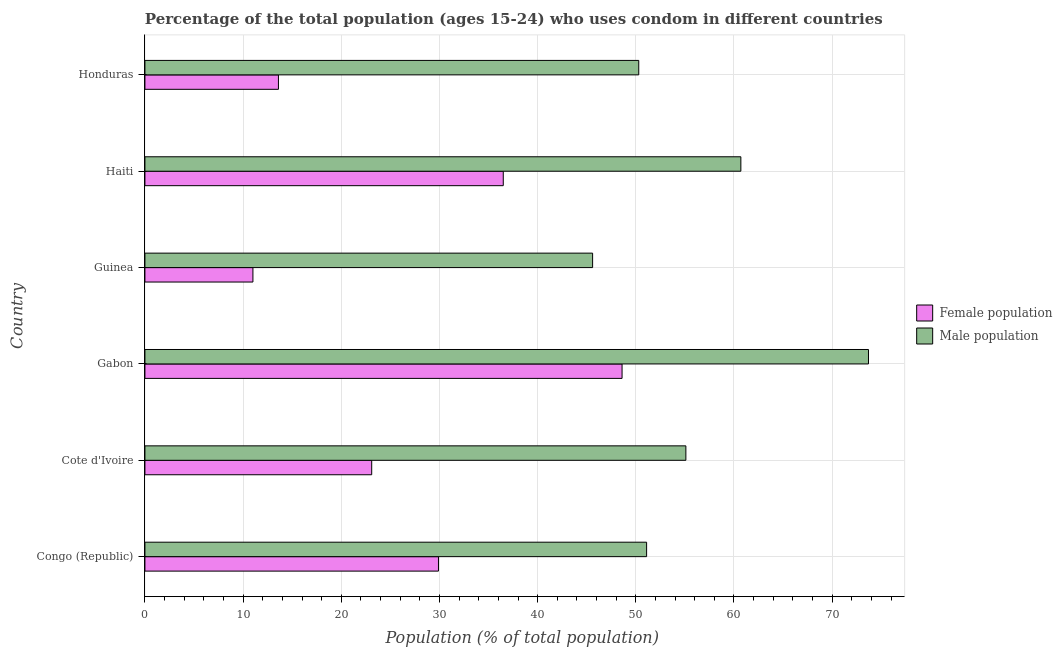Are the number of bars on each tick of the Y-axis equal?
Your answer should be very brief. Yes. How many bars are there on the 4th tick from the bottom?
Make the answer very short. 2. What is the label of the 6th group of bars from the top?
Give a very brief answer. Congo (Republic). What is the female population in Haiti?
Your response must be concise. 36.5. Across all countries, what is the maximum male population?
Give a very brief answer. 73.7. Across all countries, what is the minimum female population?
Give a very brief answer. 11. In which country was the female population maximum?
Your answer should be very brief. Gabon. In which country was the female population minimum?
Give a very brief answer. Guinea. What is the total female population in the graph?
Your answer should be compact. 162.7. What is the difference between the male population in Honduras and the female population in Haiti?
Give a very brief answer. 13.8. What is the average female population per country?
Your answer should be very brief. 27.12. What is the difference between the female population and male population in Guinea?
Offer a terse response. -34.6. In how many countries, is the male population greater than 28 %?
Offer a terse response. 6. What is the ratio of the female population in Congo (Republic) to that in Honduras?
Provide a succinct answer. 2.2. Is the female population in Congo (Republic) less than that in Haiti?
Your answer should be very brief. Yes. What is the difference between the highest and the lowest male population?
Provide a succinct answer. 28.1. In how many countries, is the female population greater than the average female population taken over all countries?
Make the answer very short. 3. What does the 2nd bar from the top in Congo (Republic) represents?
Provide a succinct answer. Female population. What does the 2nd bar from the bottom in Congo (Republic) represents?
Your answer should be compact. Male population. How many bars are there?
Make the answer very short. 12. Are all the bars in the graph horizontal?
Offer a terse response. Yes. How many countries are there in the graph?
Give a very brief answer. 6. What is the difference between two consecutive major ticks on the X-axis?
Offer a very short reply. 10. How are the legend labels stacked?
Keep it short and to the point. Vertical. What is the title of the graph?
Provide a short and direct response. Percentage of the total population (ages 15-24) who uses condom in different countries. What is the label or title of the X-axis?
Your answer should be very brief. Population (% of total population) . What is the Population (% of total population)  of Female population in Congo (Republic)?
Give a very brief answer. 29.9. What is the Population (% of total population)  in Male population in Congo (Republic)?
Offer a terse response. 51.1. What is the Population (% of total population)  of Female population in Cote d'Ivoire?
Ensure brevity in your answer.  23.1. What is the Population (% of total population)  in Male population in Cote d'Ivoire?
Provide a succinct answer. 55.1. What is the Population (% of total population)  in Female population in Gabon?
Your response must be concise. 48.6. What is the Population (% of total population)  in Male population in Gabon?
Your answer should be compact. 73.7. What is the Population (% of total population)  of Female population in Guinea?
Your response must be concise. 11. What is the Population (% of total population)  of Male population in Guinea?
Ensure brevity in your answer.  45.6. What is the Population (% of total population)  of Female population in Haiti?
Keep it short and to the point. 36.5. What is the Population (% of total population)  in Male population in Haiti?
Ensure brevity in your answer.  60.7. What is the Population (% of total population)  in Male population in Honduras?
Your response must be concise. 50.3. Across all countries, what is the maximum Population (% of total population)  of Female population?
Ensure brevity in your answer.  48.6. Across all countries, what is the maximum Population (% of total population)  in Male population?
Offer a terse response. 73.7. Across all countries, what is the minimum Population (% of total population)  of Female population?
Your answer should be very brief. 11. Across all countries, what is the minimum Population (% of total population)  in Male population?
Your answer should be compact. 45.6. What is the total Population (% of total population)  of Female population in the graph?
Keep it short and to the point. 162.7. What is the total Population (% of total population)  of Male population in the graph?
Provide a short and direct response. 336.5. What is the difference between the Population (% of total population)  of Male population in Congo (Republic) and that in Cote d'Ivoire?
Make the answer very short. -4. What is the difference between the Population (% of total population)  in Female population in Congo (Republic) and that in Gabon?
Your answer should be very brief. -18.7. What is the difference between the Population (% of total population)  in Male population in Congo (Republic) and that in Gabon?
Give a very brief answer. -22.6. What is the difference between the Population (% of total population)  in Male population in Congo (Republic) and that in Guinea?
Give a very brief answer. 5.5. What is the difference between the Population (% of total population)  in Female population in Congo (Republic) and that in Haiti?
Your response must be concise. -6.6. What is the difference between the Population (% of total population)  in Female population in Congo (Republic) and that in Honduras?
Provide a succinct answer. 16.3. What is the difference between the Population (% of total population)  in Male population in Congo (Republic) and that in Honduras?
Your answer should be very brief. 0.8. What is the difference between the Population (% of total population)  in Female population in Cote d'Ivoire and that in Gabon?
Offer a terse response. -25.5. What is the difference between the Population (% of total population)  of Male population in Cote d'Ivoire and that in Gabon?
Give a very brief answer. -18.6. What is the difference between the Population (% of total population)  of Female population in Cote d'Ivoire and that in Guinea?
Offer a very short reply. 12.1. What is the difference between the Population (% of total population)  of Male population in Cote d'Ivoire and that in Guinea?
Your answer should be very brief. 9.5. What is the difference between the Population (% of total population)  in Male population in Cote d'Ivoire and that in Haiti?
Offer a very short reply. -5.6. What is the difference between the Population (% of total population)  of Female population in Cote d'Ivoire and that in Honduras?
Ensure brevity in your answer.  9.5. What is the difference between the Population (% of total population)  of Female population in Gabon and that in Guinea?
Your answer should be very brief. 37.6. What is the difference between the Population (% of total population)  in Male population in Gabon and that in Guinea?
Offer a terse response. 28.1. What is the difference between the Population (% of total population)  in Female population in Gabon and that in Haiti?
Keep it short and to the point. 12.1. What is the difference between the Population (% of total population)  of Male population in Gabon and that in Haiti?
Provide a succinct answer. 13. What is the difference between the Population (% of total population)  in Male population in Gabon and that in Honduras?
Your answer should be very brief. 23.4. What is the difference between the Population (% of total population)  in Female population in Guinea and that in Haiti?
Offer a terse response. -25.5. What is the difference between the Population (% of total population)  in Male population in Guinea and that in Haiti?
Give a very brief answer. -15.1. What is the difference between the Population (% of total population)  in Female population in Haiti and that in Honduras?
Give a very brief answer. 22.9. What is the difference between the Population (% of total population)  of Male population in Haiti and that in Honduras?
Provide a short and direct response. 10.4. What is the difference between the Population (% of total population)  of Female population in Congo (Republic) and the Population (% of total population)  of Male population in Cote d'Ivoire?
Your answer should be compact. -25.2. What is the difference between the Population (% of total population)  in Female population in Congo (Republic) and the Population (% of total population)  in Male population in Gabon?
Make the answer very short. -43.8. What is the difference between the Population (% of total population)  in Female population in Congo (Republic) and the Population (% of total population)  in Male population in Guinea?
Make the answer very short. -15.7. What is the difference between the Population (% of total population)  in Female population in Congo (Republic) and the Population (% of total population)  in Male population in Haiti?
Provide a short and direct response. -30.8. What is the difference between the Population (% of total population)  in Female population in Congo (Republic) and the Population (% of total population)  in Male population in Honduras?
Offer a terse response. -20.4. What is the difference between the Population (% of total population)  in Female population in Cote d'Ivoire and the Population (% of total population)  in Male population in Gabon?
Offer a very short reply. -50.6. What is the difference between the Population (% of total population)  of Female population in Cote d'Ivoire and the Population (% of total population)  of Male population in Guinea?
Provide a succinct answer. -22.5. What is the difference between the Population (% of total population)  in Female population in Cote d'Ivoire and the Population (% of total population)  in Male population in Haiti?
Offer a terse response. -37.6. What is the difference between the Population (% of total population)  of Female population in Cote d'Ivoire and the Population (% of total population)  of Male population in Honduras?
Provide a short and direct response. -27.2. What is the difference between the Population (% of total population)  of Female population in Guinea and the Population (% of total population)  of Male population in Haiti?
Provide a short and direct response. -49.7. What is the difference between the Population (% of total population)  in Female population in Guinea and the Population (% of total population)  in Male population in Honduras?
Your answer should be compact. -39.3. What is the difference between the Population (% of total population)  in Female population in Haiti and the Population (% of total population)  in Male population in Honduras?
Your answer should be compact. -13.8. What is the average Population (% of total population)  of Female population per country?
Provide a succinct answer. 27.12. What is the average Population (% of total population)  of Male population per country?
Your answer should be compact. 56.08. What is the difference between the Population (% of total population)  of Female population and Population (% of total population)  of Male population in Congo (Republic)?
Keep it short and to the point. -21.2. What is the difference between the Population (% of total population)  of Female population and Population (% of total population)  of Male population in Cote d'Ivoire?
Offer a terse response. -32. What is the difference between the Population (% of total population)  of Female population and Population (% of total population)  of Male population in Gabon?
Make the answer very short. -25.1. What is the difference between the Population (% of total population)  in Female population and Population (% of total population)  in Male population in Guinea?
Offer a terse response. -34.6. What is the difference between the Population (% of total population)  in Female population and Population (% of total population)  in Male population in Haiti?
Ensure brevity in your answer.  -24.2. What is the difference between the Population (% of total population)  of Female population and Population (% of total population)  of Male population in Honduras?
Make the answer very short. -36.7. What is the ratio of the Population (% of total population)  in Female population in Congo (Republic) to that in Cote d'Ivoire?
Provide a short and direct response. 1.29. What is the ratio of the Population (% of total population)  of Male population in Congo (Republic) to that in Cote d'Ivoire?
Give a very brief answer. 0.93. What is the ratio of the Population (% of total population)  of Female population in Congo (Republic) to that in Gabon?
Your answer should be compact. 0.62. What is the ratio of the Population (% of total population)  of Male population in Congo (Republic) to that in Gabon?
Keep it short and to the point. 0.69. What is the ratio of the Population (% of total population)  of Female population in Congo (Republic) to that in Guinea?
Your answer should be very brief. 2.72. What is the ratio of the Population (% of total population)  in Male population in Congo (Republic) to that in Guinea?
Provide a succinct answer. 1.12. What is the ratio of the Population (% of total population)  in Female population in Congo (Republic) to that in Haiti?
Offer a very short reply. 0.82. What is the ratio of the Population (% of total population)  of Male population in Congo (Republic) to that in Haiti?
Keep it short and to the point. 0.84. What is the ratio of the Population (% of total population)  of Female population in Congo (Republic) to that in Honduras?
Your response must be concise. 2.2. What is the ratio of the Population (% of total population)  of Male population in Congo (Republic) to that in Honduras?
Provide a short and direct response. 1.02. What is the ratio of the Population (% of total population)  of Female population in Cote d'Ivoire to that in Gabon?
Keep it short and to the point. 0.48. What is the ratio of the Population (% of total population)  of Male population in Cote d'Ivoire to that in Gabon?
Make the answer very short. 0.75. What is the ratio of the Population (% of total population)  in Female population in Cote d'Ivoire to that in Guinea?
Offer a terse response. 2.1. What is the ratio of the Population (% of total population)  of Male population in Cote d'Ivoire to that in Guinea?
Keep it short and to the point. 1.21. What is the ratio of the Population (% of total population)  in Female population in Cote d'Ivoire to that in Haiti?
Ensure brevity in your answer.  0.63. What is the ratio of the Population (% of total population)  in Male population in Cote d'Ivoire to that in Haiti?
Provide a short and direct response. 0.91. What is the ratio of the Population (% of total population)  in Female population in Cote d'Ivoire to that in Honduras?
Ensure brevity in your answer.  1.7. What is the ratio of the Population (% of total population)  of Male population in Cote d'Ivoire to that in Honduras?
Offer a very short reply. 1.1. What is the ratio of the Population (% of total population)  of Female population in Gabon to that in Guinea?
Offer a very short reply. 4.42. What is the ratio of the Population (% of total population)  of Male population in Gabon to that in Guinea?
Ensure brevity in your answer.  1.62. What is the ratio of the Population (% of total population)  of Female population in Gabon to that in Haiti?
Give a very brief answer. 1.33. What is the ratio of the Population (% of total population)  of Male population in Gabon to that in Haiti?
Your answer should be very brief. 1.21. What is the ratio of the Population (% of total population)  in Female population in Gabon to that in Honduras?
Give a very brief answer. 3.57. What is the ratio of the Population (% of total population)  of Male population in Gabon to that in Honduras?
Offer a terse response. 1.47. What is the ratio of the Population (% of total population)  of Female population in Guinea to that in Haiti?
Make the answer very short. 0.3. What is the ratio of the Population (% of total population)  in Male population in Guinea to that in Haiti?
Provide a short and direct response. 0.75. What is the ratio of the Population (% of total population)  in Female population in Guinea to that in Honduras?
Your answer should be very brief. 0.81. What is the ratio of the Population (% of total population)  in Male population in Guinea to that in Honduras?
Ensure brevity in your answer.  0.91. What is the ratio of the Population (% of total population)  in Female population in Haiti to that in Honduras?
Offer a very short reply. 2.68. What is the ratio of the Population (% of total population)  of Male population in Haiti to that in Honduras?
Your answer should be compact. 1.21. What is the difference between the highest and the second highest Population (% of total population)  of Male population?
Make the answer very short. 13. What is the difference between the highest and the lowest Population (% of total population)  in Female population?
Offer a very short reply. 37.6. What is the difference between the highest and the lowest Population (% of total population)  of Male population?
Provide a succinct answer. 28.1. 